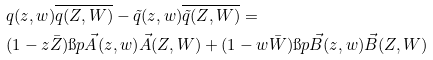Convert formula to latex. <formula><loc_0><loc_0><loc_500><loc_500>& q ( z , w ) \overline { q ( Z , W ) } - \tilde { q } ( z , w ) \overline { \tilde { q } ( Z , W ) } = \\ & ( 1 - z \bar { Z } ) \i p { \vec { A } ( z , w ) } { \vec { A } ( Z , W ) } + ( 1 - w \bar { W } ) \i p { \vec { B } ( z , w ) } { \vec { B } ( Z , W ) }</formula> 